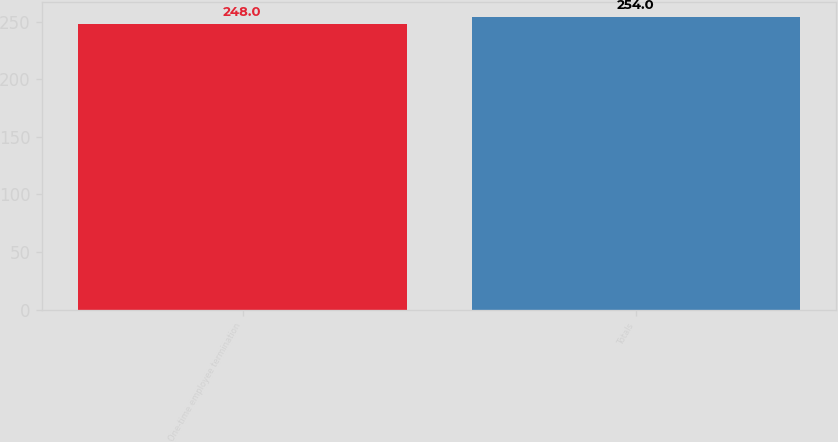Convert chart to OTSL. <chart><loc_0><loc_0><loc_500><loc_500><bar_chart><fcel>One-time employee termination<fcel>Totals<nl><fcel>248<fcel>254<nl></chart> 